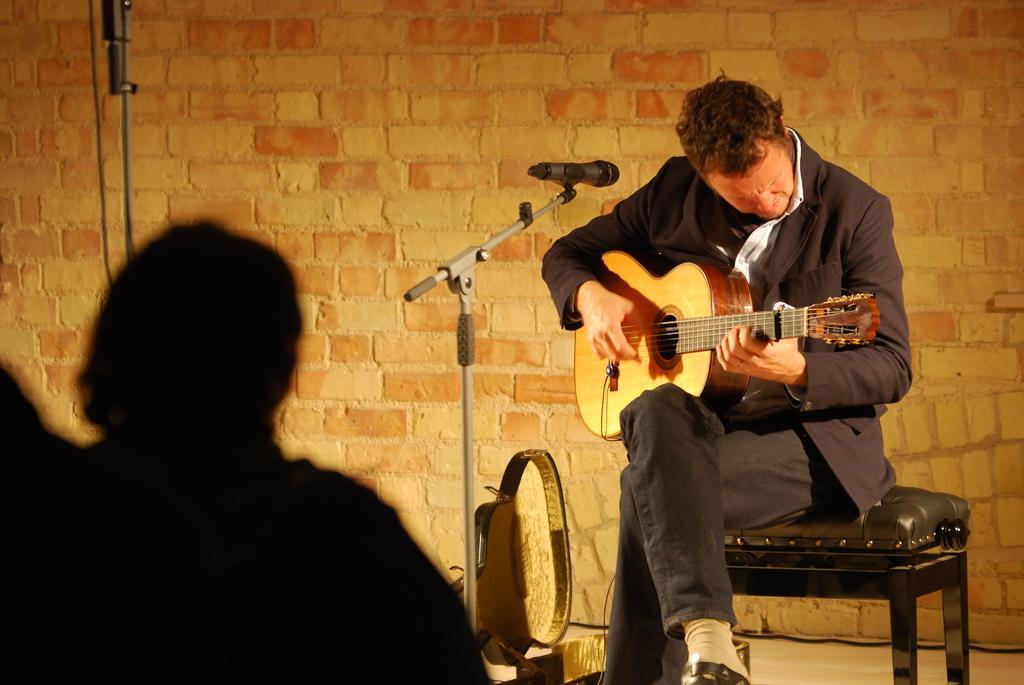Describe this image in one or two sentences. In this image there is a person sitting in a chair playing a musical instrument in front of him there is a microphone and at the left side of the image there is a shadow and at the background of the image it is a brick wall. 